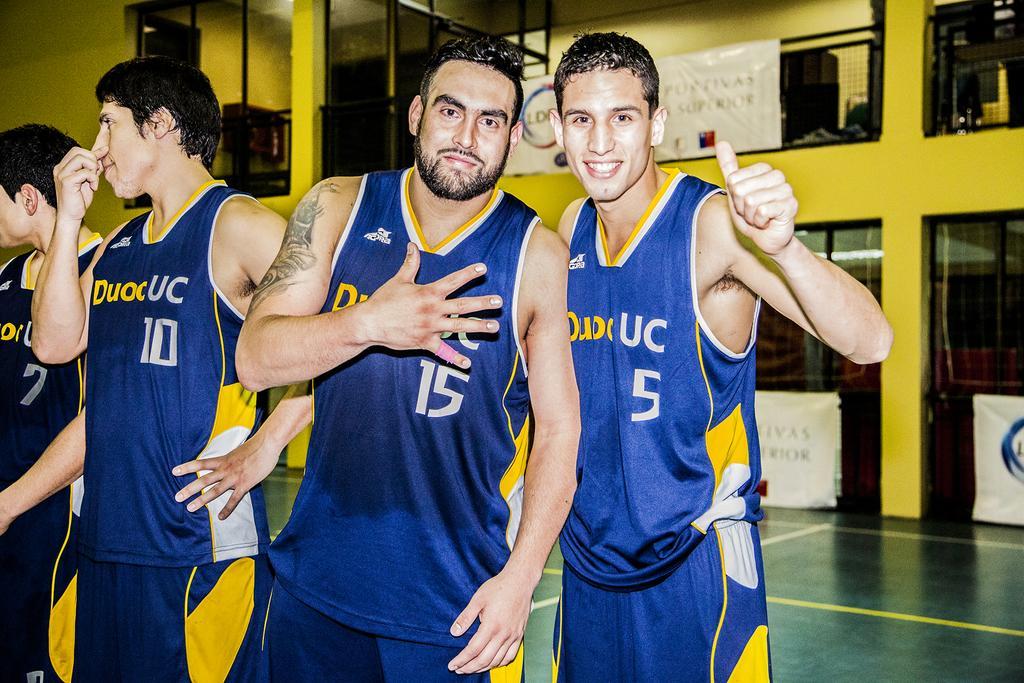Please provide a concise description of this image. In this image I can see there are persons standing on the floor. And at the back there is a banner attached to the fence. 